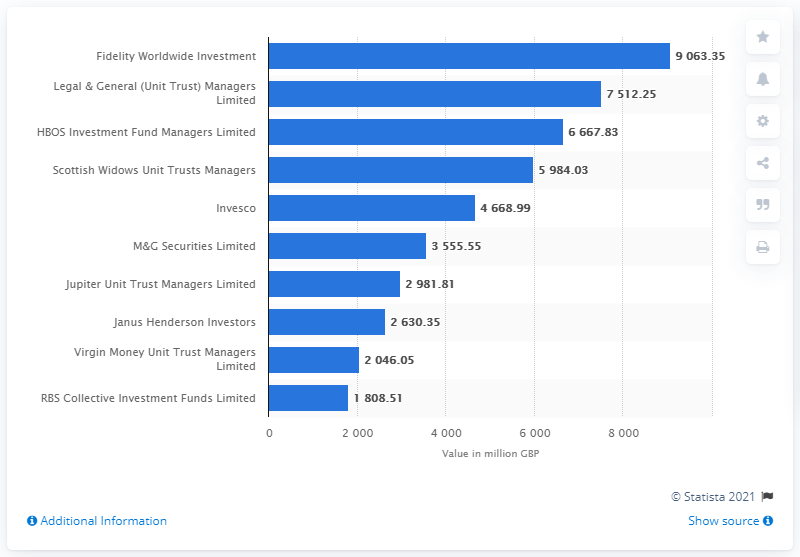Indicate a few pertinent items in this graphic. Virgin Money Unit Trust Managers Limited managed to maintain its position among the top ten companies. In July 2019, the value of Fidelity Worldwide Investment's ISA funds was 9063.35... 